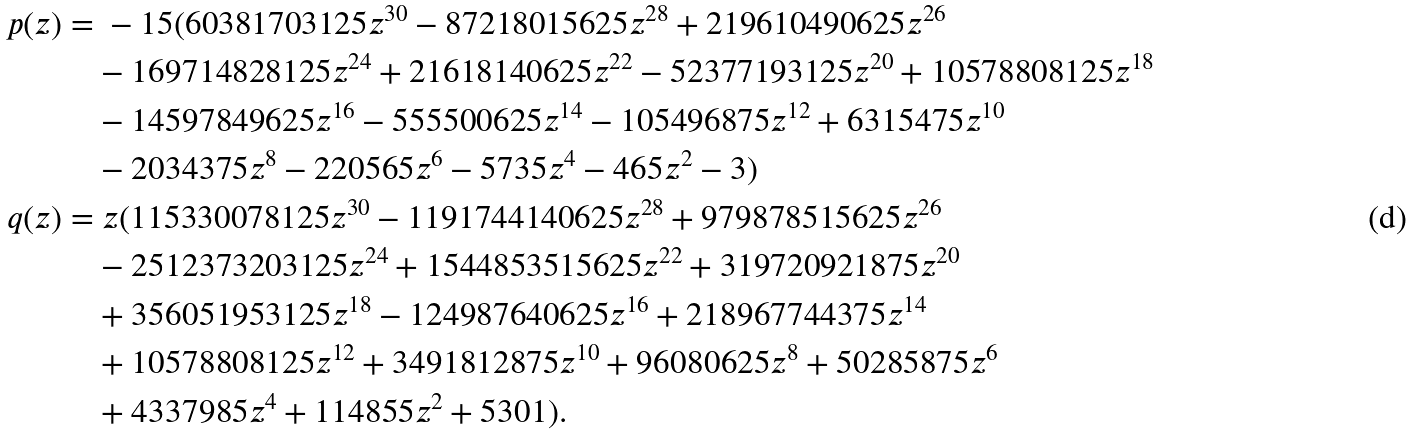Convert formula to latex. <formula><loc_0><loc_0><loc_500><loc_500>p ( z ) = & \ - 1 5 ( 6 0 3 8 1 7 0 3 1 2 5 z ^ { 3 0 } - 8 7 2 1 8 0 1 5 6 2 5 z ^ { 2 8 } + 2 1 9 6 1 0 4 9 0 6 2 5 z ^ { 2 6 } \\ & - 1 6 9 7 1 4 8 2 8 1 2 5 z ^ { 2 4 } + 2 1 6 1 8 1 4 0 6 2 5 z ^ { 2 2 } - 5 2 3 7 7 1 9 3 1 2 5 z ^ { 2 0 } + 1 0 5 7 8 8 0 8 1 2 5 z ^ { 1 8 } \\ & - 1 4 5 9 7 8 4 9 6 2 5 z ^ { 1 6 } - 5 5 5 5 0 0 6 2 5 z ^ { 1 4 } - 1 0 5 4 9 6 8 7 5 z ^ { 1 2 } + 6 3 1 5 4 7 5 z ^ { 1 0 } \\ & - 2 0 3 4 3 7 5 z ^ { 8 } - 2 2 0 5 6 5 z ^ { 6 } - 5 7 3 5 z ^ { 4 } - 4 6 5 z ^ { 2 } - 3 ) \\ q ( z ) = & \ z ( 1 1 5 3 3 0 0 7 8 1 2 5 z ^ { 3 0 } - 1 1 9 1 7 4 4 1 4 0 6 2 5 z ^ { 2 8 } + 9 7 9 8 7 8 5 1 5 6 2 5 z ^ { 2 6 } \\ & - 2 5 1 2 3 7 3 2 0 3 1 2 5 z ^ { 2 4 } + 1 5 4 4 8 5 3 5 1 5 6 2 5 z ^ { 2 2 } + 3 1 9 7 2 0 9 2 1 8 7 5 z ^ { 2 0 } \\ & + 3 5 6 0 5 1 9 5 3 1 2 5 z ^ { 1 8 } - 1 2 4 9 8 7 6 4 0 6 2 5 z ^ { 1 6 } + 2 1 8 9 6 7 7 4 4 3 7 5 z ^ { 1 4 } \\ & + 1 0 5 7 8 8 0 8 1 2 5 z ^ { 1 2 } + 3 4 9 1 8 1 2 8 7 5 z ^ { 1 0 } + 9 6 0 8 0 6 2 5 z ^ { 8 } + 5 0 2 8 5 8 7 5 z ^ { 6 } \\ & + 4 3 3 7 9 8 5 z ^ { 4 } + 1 1 4 8 5 5 z ^ { 2 } + 5 3 0 1 ) .</formula> 